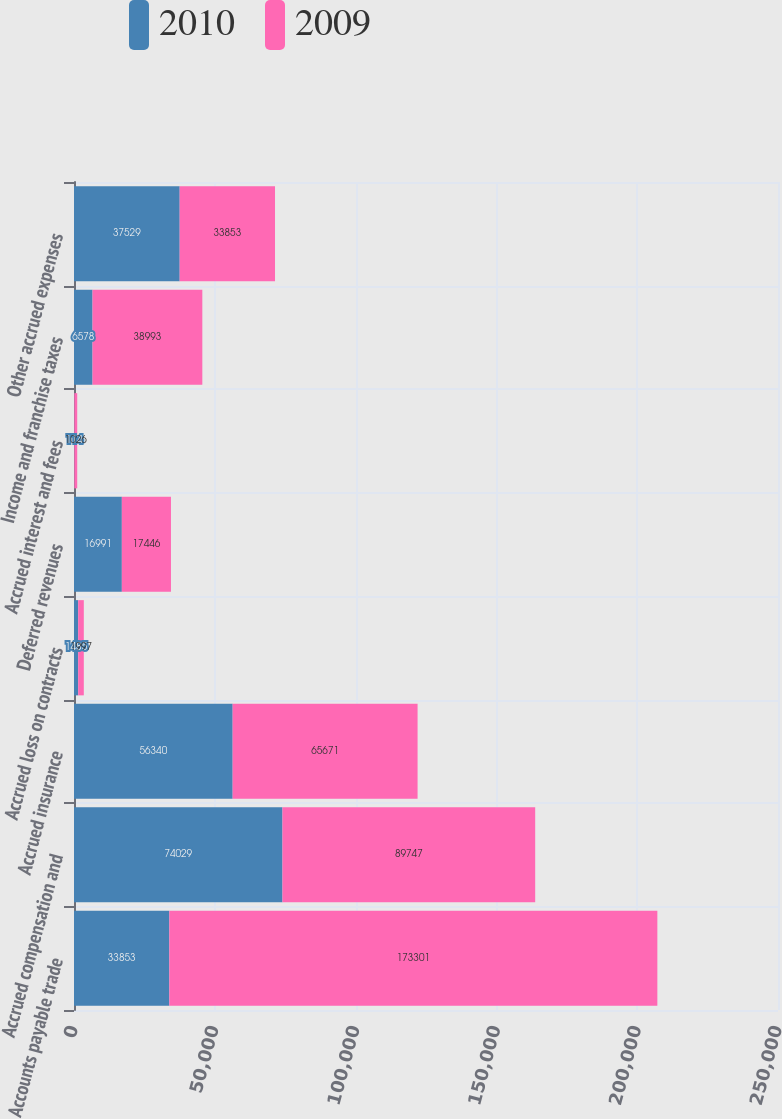<chart> <loc_0><loc_0><loc_500><loc_500><stacked_bar_chart><ecel><fcel>Accounts payable trade<fcel>Accrued compensation and<fcel>Accrued insurance<fcel>Accrued loss on contracts<fcel>Deferred revenues<fcel>Accrued interest and fees<fcel>Income and franchise taxes<fcel>Other accrued expenses<nl><fcel>2010<fcel>33853<fcel>74029<fcel>56340<fcel>1485<fcel>16991<fcel>114<fcel>6578<fcel>37529<nl><fcel>2009<fcel>173301<fcel>89747<fcel>65671<fcel>1997<fcel>17446<fcel>1026<fcel>38993<fcel>33853<nl></chart> 